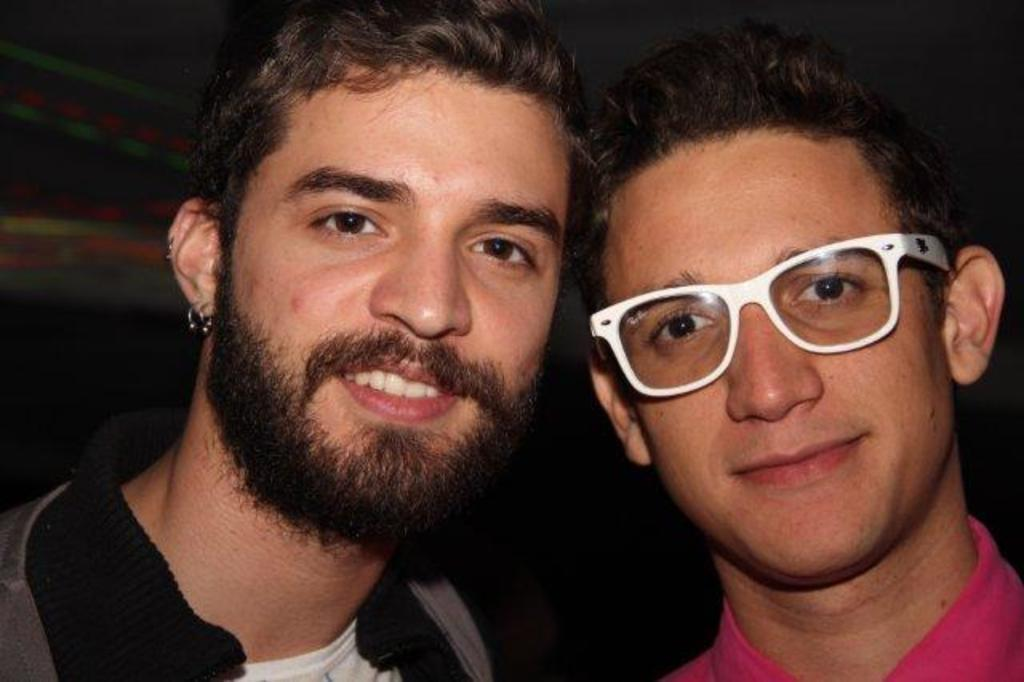How many people are in the image? There are two men in the image. What is the man wearing a grey jacket doing? The facts provided do not specify any actions or activities of the men. What is the other man wearing? The other man is wearing a pink shirt and spectacles. What type of plant is being adjusted by the man in the image? There is no plant present in the image, and the man is not adjusting anything. 